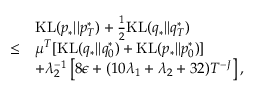<formula> <loc_0><loc_0><loc_500><loc_500>\begin{array} { r l } & { K L ( p _ { * } | | p _ { T } ^ { * } ) + \frac { 1 } { 2 } K L ( q _ { * } | | q _ { T } ^ { * } ) } \\ { \leq } & { \mu ^ { T } [ K L ( q _ { * } | | q _ { 0 } ^ { * } ) + K L ( p _ { * } | | p _ { 0 } ^ { * } ) ] } \\ & { + \lambda _ { 2 } ^ { - 1 } \left [ 8 \epsilon + ( 1 0 \lambda _ { 1 } + \lambda _ { 2 } + 3 2 ) T ^ { - J } \right ] , } \end{array}</formula> 